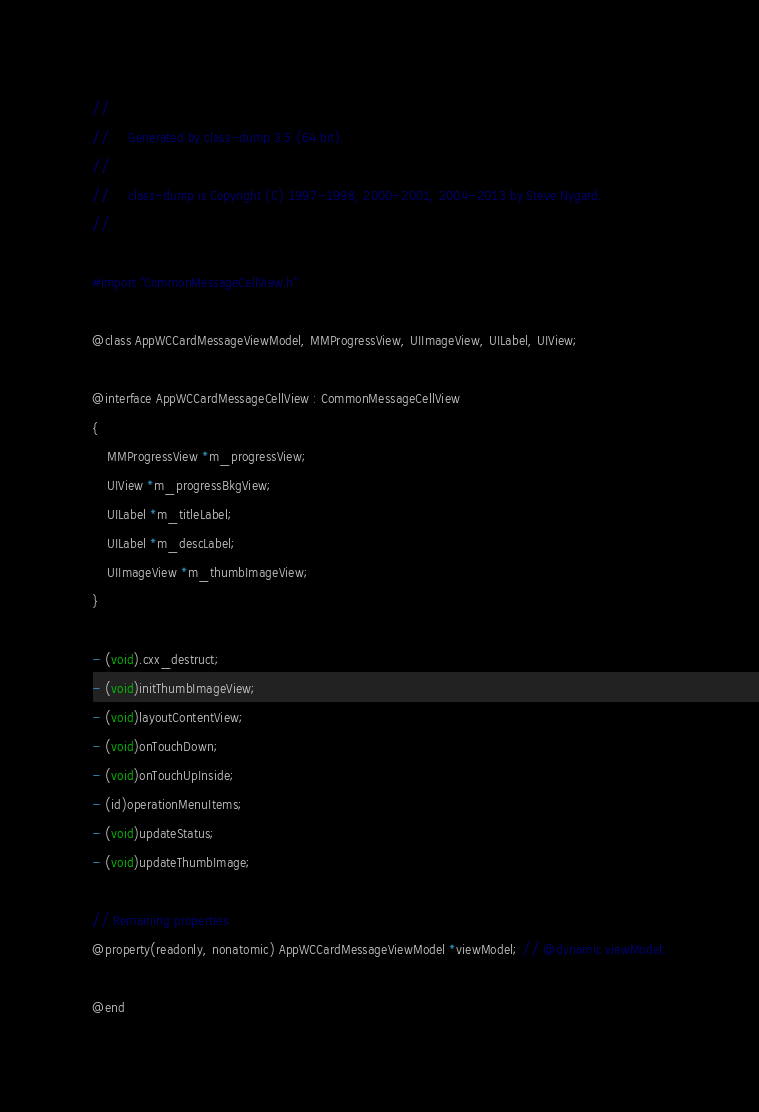<code> <loc_0><loc_0><loc_500><loc_500><_C_>//
//     Generated by class-dump 3.5 (64 bit).
//
//     class-dump is Copyright (C) 1997-1998, 2000-2001, 2004-2013 by Steve Nygard.
//

#import "CommonMessageCellView.h"

@class AppWCCardMessageViewModel, MMProgressView, UIImageView, UILabel, UIView;

@interface AppWCCardMessageCellView : CommonMessageCellView
{
    MMProgressView *m_progressView;
    UIView *m_progressBkgView;
    UILabel *m_titleLabel;
    UILabel *m_descLabel;
    UIImageView *m_thumbImageView;
}

- (void).cxx_destruct;
- (void)initThumbImageView;
- (void)layoutContentView;
- (void)onTouchDown;
- (void)onTouchUpInside;
- (id)operationMenuItems;
- (void)updateStatus;
- (void)updateThumbImage;

// Remaining properties
@property(readonly, nonatomic) AppWCCardMessageViewModel *viewModel; // @dynamic viewModel;

@end

</code> 